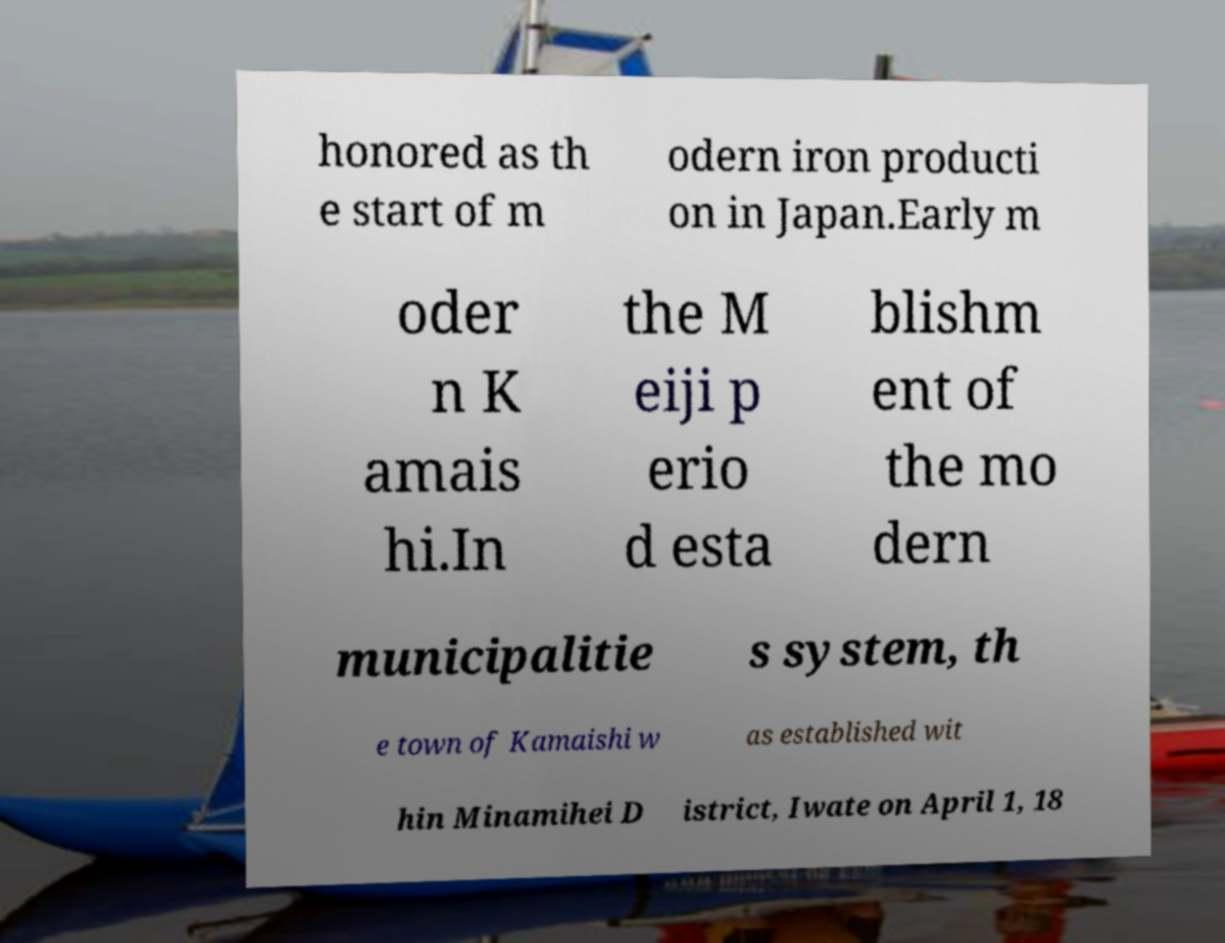What messages or text are displayed in this image? I need them in a readable, typed format. honored as th e start of m odern iron producti on in Japan.Early m oder n K amais hi.In the M eiji p erio d esta blishm ent of the mo dern municipalitie s system, th e town of Kamaishi w as established wit hin Minamihei D istrict, Iwate on April 1, 18 